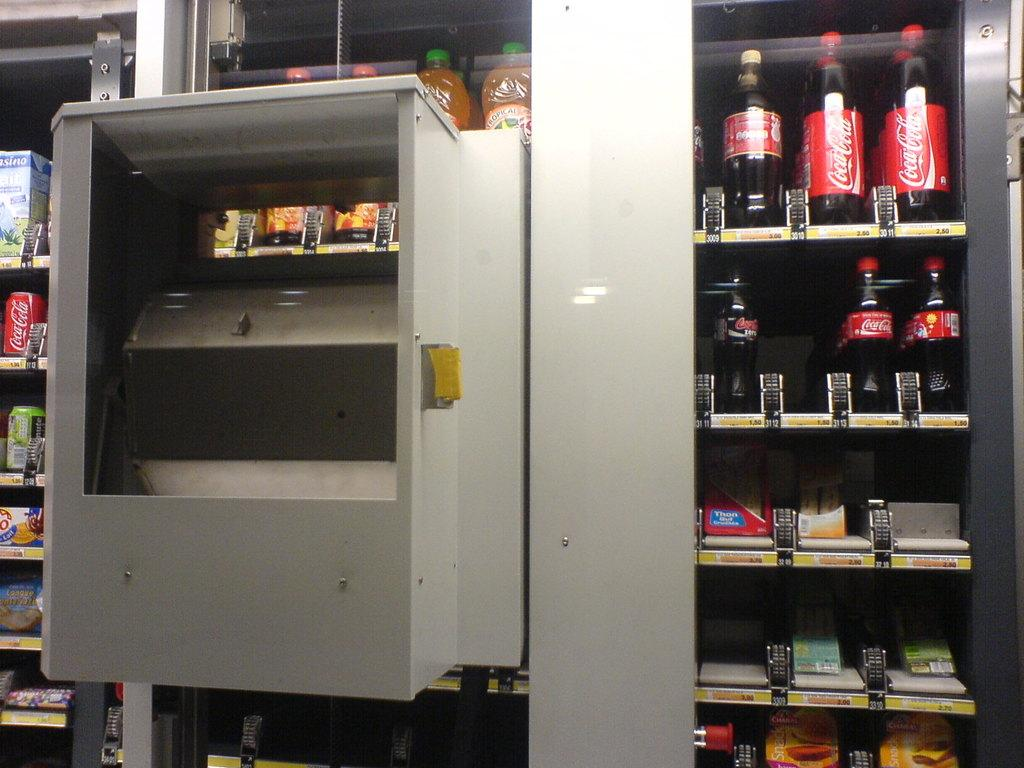<image>
Render a clear and concise summary of the photo. The vending machine stocks different Coca Cola products. 